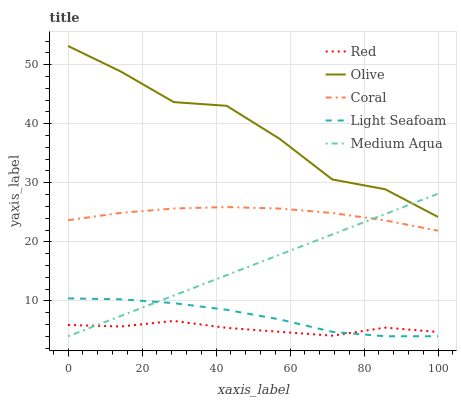Does Red have the minimum area under the curve?
Answer yes or no. Yes. Does Olive have the maximum area under the curve?
Answer yes or no. Yes. Does Coral have the minimum area under the curve?
Answer yes or no. No. Does Coral have the maximum area under the curve?
Answer yes or no. No. Is Medium Aqua the smoothest?
Answer yes or no. Yes. Is Olive the roughest?
Answer yes or no. Yes. Is Coral the smoothest?
Answer yes or no. No. Is Coral the roughest?
Answer yes or no. No. Does Light Seafoam have the lowest value?
Answer yes or no. Yes. Does Coral have the lowest value?
Answer yes or no. No. Does Olive have the highest value?
Answer yes or no. Yes. Does Coral have the highest value?
Answer yes or no. No. Is Red less than Olive?
Answer yes or no. Yes. Is Coral greater than Red?
Answer yes or no. Yes. Does Medium Aqua intersect Light Seafoam?
Answer yes or no. Yes. Is Medium Aqua less than Light Seafoam?
Answer yes or no. No. Is Medium Aqua greater than Light Seafoam?
Answer yes or no. No. Does Red intersect Olive?
Answer yes or no. No. 